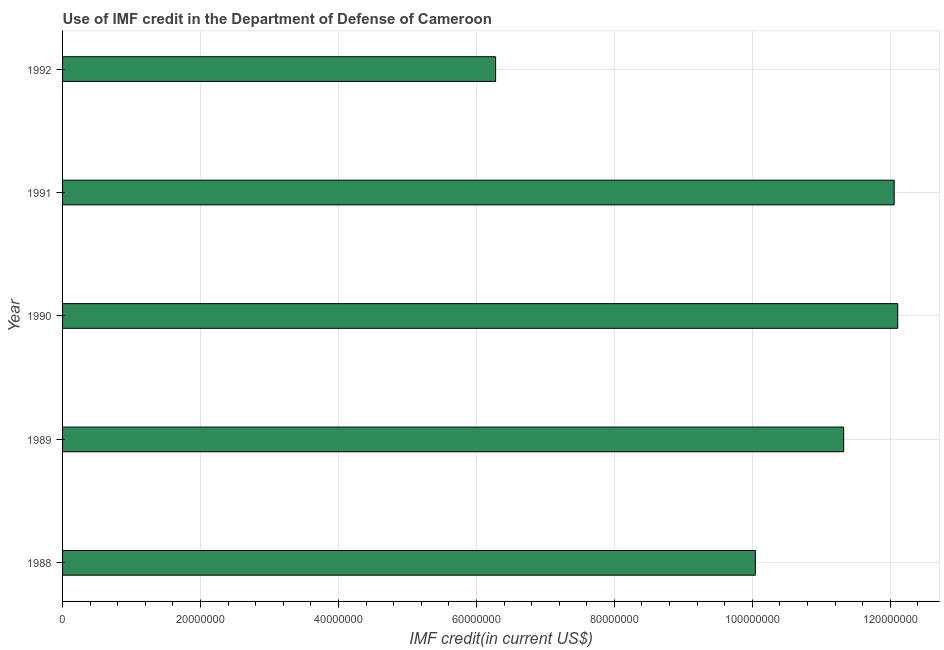What is the title of the graph?
Ensure brevity in your answer.  Use of IMF credit in the Department of Defense of Cameroon. What is the label or title of the X-axis?
Ensure brevity in your answer.  IMF credit(in current US$). What is the use of imf credit in dod in 1988?
Provide a succinct answer. 1.00e+08. Across all years, what is the maximum use of imf credit in dod?
Offer a very short reply. 1.21e+08. Across all years, what is the minimum use of imf credit in dod?
Offer a terse response. 6.28e+07. In which year was the use of imf credit in dod maximum?
Offer a terse response. 1990. What is the sum of the use of imf credit in dod?
Your answer should be compact. 5.18e+08. What is the difference between the use of imf credit in dod in 1990 and 1992?
Offer a terse response. 5.83e+07. What is the average use of imf credit in dod per year?
Offer a terse response. 1.04e+08. What is the median use of imf credit in dod?
Offer a terse response. 1.13e+08. Do a majority of the years between 1990 and 1989 (inclusive) have use of imf credit in dod greater than 56000000 US$?
Ensure brevity in your answer.  No. What is the difference between the highest and the second highest use of imf credit in dod?
Your answer should be very brief. 5.17e+05. What is the difference between the highest and the lowest use of imf credit in dod?
Provide a short and direct response. 5.83e+07. In how many years, is the use of imf credit in dod greater than the average use of imf credit in dod taken over all years?
Keep it short and to the point. 3. How many bars are there?
Make the answer very short. 5. Are all the bars in the graph horizontal?
Your answer should be very brief. Yes. Are the values on the major ticks of X-axis written in scientific E-notation?
Ensure brevity in your answer.  No. What is the IMF credit(in current US$) of 1988?
Keep it short and to the point. 1.00e+08. What is the IMF credit(in current US$) in 1989?
Provide a short and direct response. 1.13e+08. What is the IMF credit(in current US$) in 1990?
Your answer should be compact. 1.21e+08. What is the IMF credit(in current US$) in 1991?
Provide a short and direct response. 1.21e+08. What is the IMF credit(in current US$) of 1992?
Your answer should be very brief. 6.28e+07. What is the difference between the IMF credit(in current US$) in 1988 and 1989?
Make the answer very short. -1.28e+07. What is the difference between the IMF credit(in current US$) in 1988 and 1990?
Provide a short and direct response. -2.06e+07. What is the difference between the IMF credit(in current US$) in 1988 and 1991?
Keep it short and to the point. -2.01e+07. What is the difference between the IMF credit(in current US$) in 1988 and 1992?
Offer a terse response. 3.77e+07. What is the difference between the IMF credit(in current US$) in 1989 and 1990?
Make the answer very short. -7.84e+06. What is the difference between the IMF credit(in current US$) in 1989 and 1991?
Ensure brevity in your answer.  -7.32e+06. What is the difference between the IMF credit(in current US$) in 1989 and 1992?
Your answer should be very brief. 5.05e+07. What is the difference between the IMF credit(in current US$) in 1990 and 1991?
Your answer should be very brief. 5.17e+05. What is the difference between the IMF credit(in current US$) in 1990 and 1992?
Keep it short and to the point. 5.83e+07. What is the difference between the IMF credit(in current US$) in 1991 and 1992?
Give a very brief answer. 5.78e+07. What is the ratio of the IMF credit(in current US$) in 1988 to that in 1989?
Your answer should be very brief. 0.89. What is the ratio of the IMF credit(in current US$) in 1988 to that in 1990?
Make the answer very short. 0.83. What is the ratio of the IMF credit(in current US$) in 1988 to that in 1991?
Your response must be concise. 0.83. What is the ratio of the IMF credit(in current US$) in 1988 to that in 1992?
Offer a terse response. 1.6. What is the ratio of the IMF credit(in current US$) in 1989 to that in 1990?
Give a very brief answer. 0.94. What is the ratio of the IMF credit(in current US$) in 1989 to that in 1991?
Your answer should be compact. 0.94. What is the ratio of the IMF credit(in current US$) in 1989 to that in 1992?
Keep it short and to the point. 1.8. What is the ratio of the IMF credit(in current US$) in 1990 to that in 1991?
Your response must be concise. 1. What is the ratio of the IMF credit(in current US$) in 1990 to that in 1992?
Make the answer very short. 1.93. What is the ratio of the IMF credit(in current US$) in 1991 to that in 1992?
Your answer should be very brief. 1.92. 